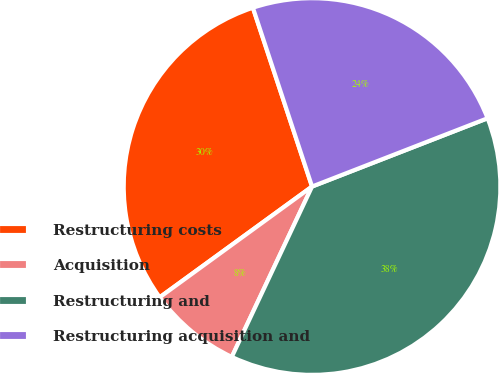Convert chart to OTSL. <chart><loc_0><loc_0><loc_500><loc_500><pie_chart><fcel>Restructuring costs<fcel>Acquisition<fcel>Restructuring and<fcel>Restructuring acquisition and<nl><fcel>29.92%<fcel>7.99%<fcel>37.91%<fcel>24.18%<nl></chart> 